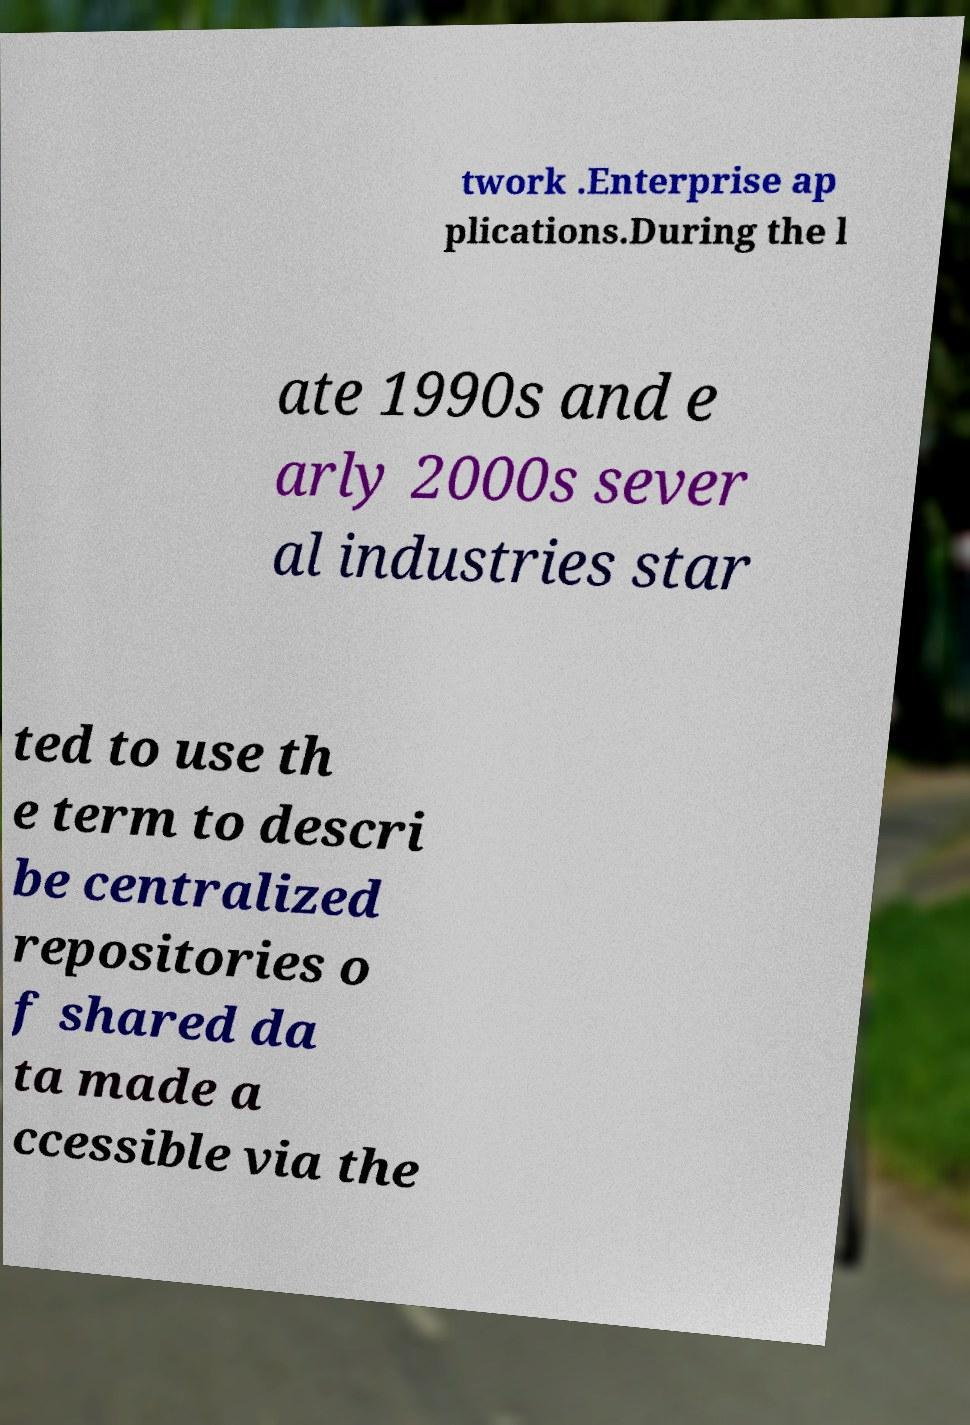Could you assist in decoding the text presented in this image and type it out clearly? twork .Enterprise ap plications.During the l ate 1990s and e arly 2000s sever al industries star ted to use th e term to descri be centralized repositories o f shared da ta made a ccessible via the 